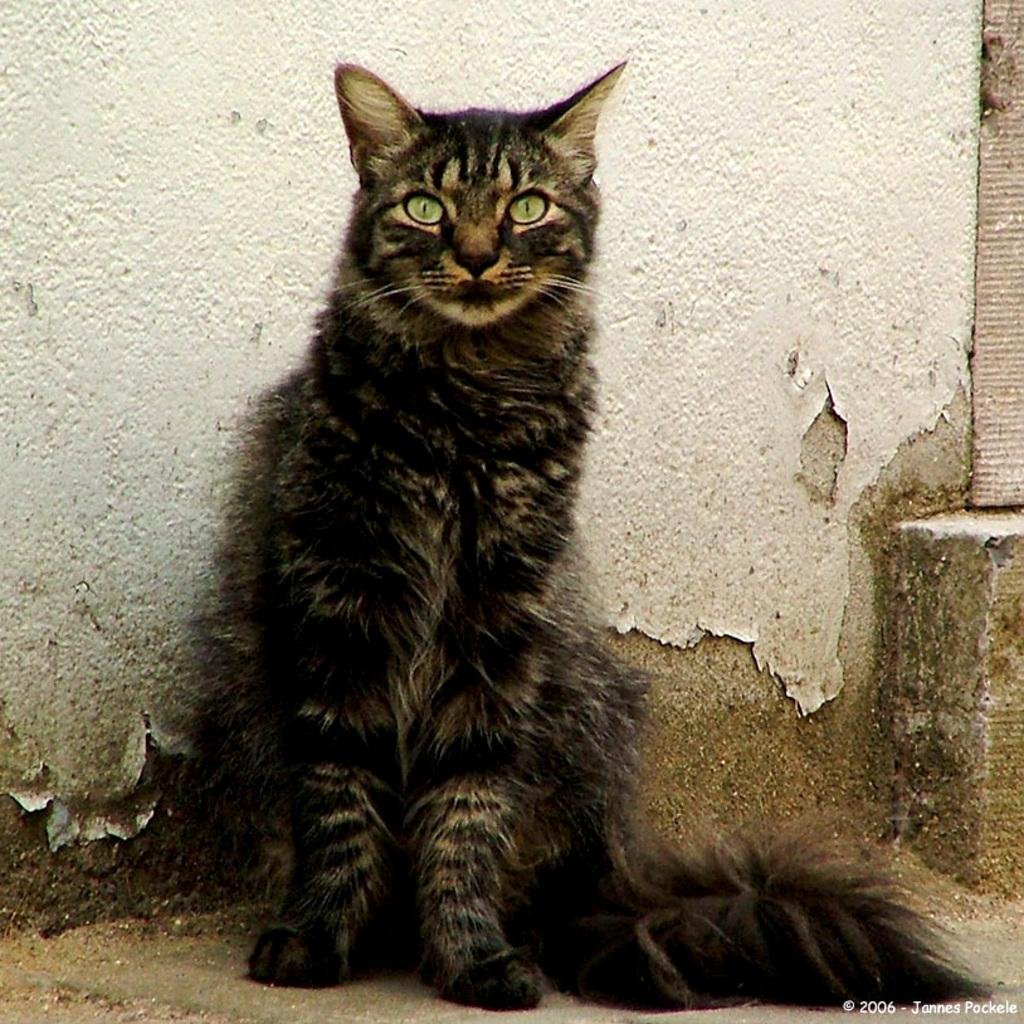What is the main subject of the image? There is a cat in the center of the image. What can be seen in the background of the image? There is a wall in the background of the image. What is located at the bottom of the image? There is a walkway at the bottom of the image. What type of ink is the cat using to write on the wall in the image? There is no ink or writing present in the image; the cat is not depicted as engaging in any such activity. 